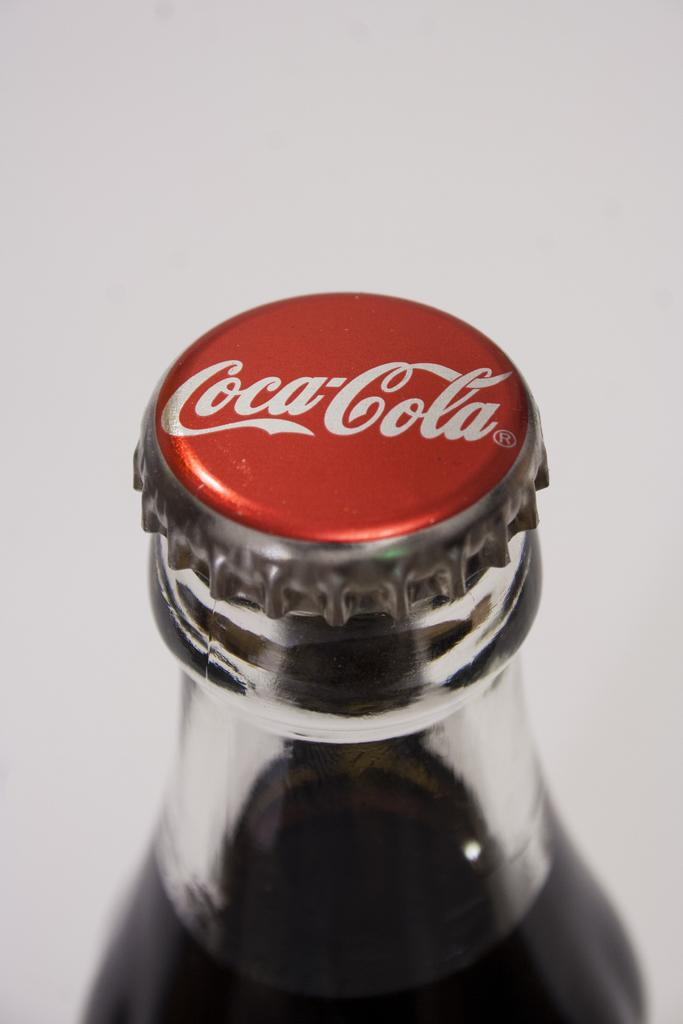What type of beverage is associated with the bottle in the image? The bottle in the image is a Coca-Cola bottle, which is associated with a soft drink. What type of religion is practiced in the middle of the image? There is no reference to religion or any middle area in the image, as it only features a Coca-Cola bottle. 